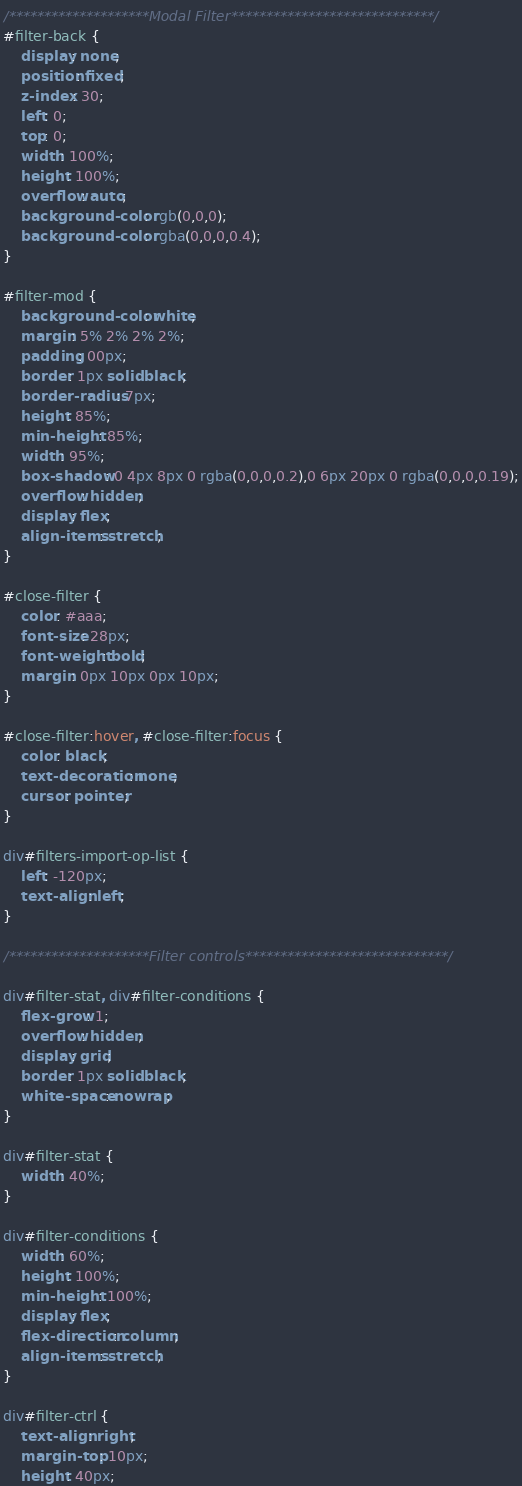Convert code to text. <code><loc_0><loc_0><loc_500><loc_500><_CSS_>/********************Modal Filter*****************************/
#filter-back {
    display: none;
    position: fixed;
    z-index: 30;
    left: 0;
    top: 0;
    width: 100%;
    height: 100%;
    overflow: auto;
    background-color: rgb(0,0,0);
    background-color: rgba(0,0,0,0.4);
}

#filter-mod {
    background-color: white;
    margin: 5% 2% 2% 2%; 
    padding: 00px;
    border: 1px solid black;
    border-radius: 7px;
    height: 85%; 
    min-height: 85%;
    width: 95%;
    box-shadow: 0 4px 8px 0 rgba(0,0,0,0.2),0 6px 20px 0 rgba(0,0,0,0.19);
    overflow: hidden;
    display: flex;
    align-items: stretch;
}

#close-filter {
    color: #aaa;
    font-size: 28px;
    font-weight: bold;
    margin: 0px 10px 0px 10px;
}

#close-filter:hover, #close-filter:focus {
    color: black;
    text-decoration: none;
    cursor: pointer;
} 

div#filters-import-op-list {
    left: -120px;
    text-align: left;
}

/********************Filter controls*****************************/

div#filter-stat, div#filter-conditions {
    flex-grow: 1;
    overflow: hidden;
    display: grid;
    border: 1px solid black;
    white-space: nowrap;
}

div#filter-stat {
    width: 40%;
}

div#filter-conditions {
    width: 60%;
    height: 100%;
    min-height: 100%;
    display: flex;
    flex-direction: column;
    align-items: stretch;
}

div#filter-ctrl {
    text-align: right;
    margin-top: 10px;
    height: 40px;</code> 